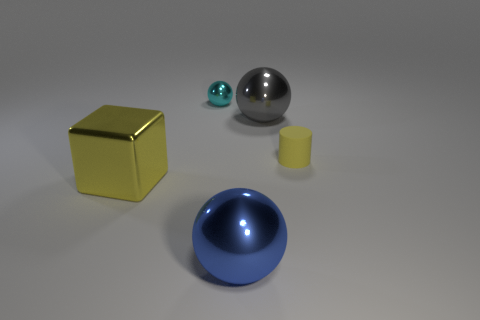Is the color of the large metal sphere that is behind the blue thing the same as the tiny rubber object behind the large yellow metal block?
Provide a succinct answer. No. Is there any other thing that has the same color as the metallic block?
Make the answer very short. Yes. What is the color of the tiny rubber object?
Make the answer very short. Yellow. Is there a red metal thing?
Your answer should be compact. No. There is a small rubber thing; are there any tiny matte cylinders on the right side of it?
Provide a succinct answer. No. There is a cyan thing that is the same shape as the large blue thing; what is its material?
Make the answer very short. Metal. Is there any other thing that has the same material as the gray sphere?
Keep it short and to the point. Yes. How many other things are the same shape as the matte object?
Provide a short and direct response. 0. What number of small things are on the left side of the big metal ball that is in front of the big ball behind the blue metallic ball?
Keep it short and to the point. 1. What number of other metallic objects have the same shape as the cyan metal object?
Your answer should be very brief. 2. 